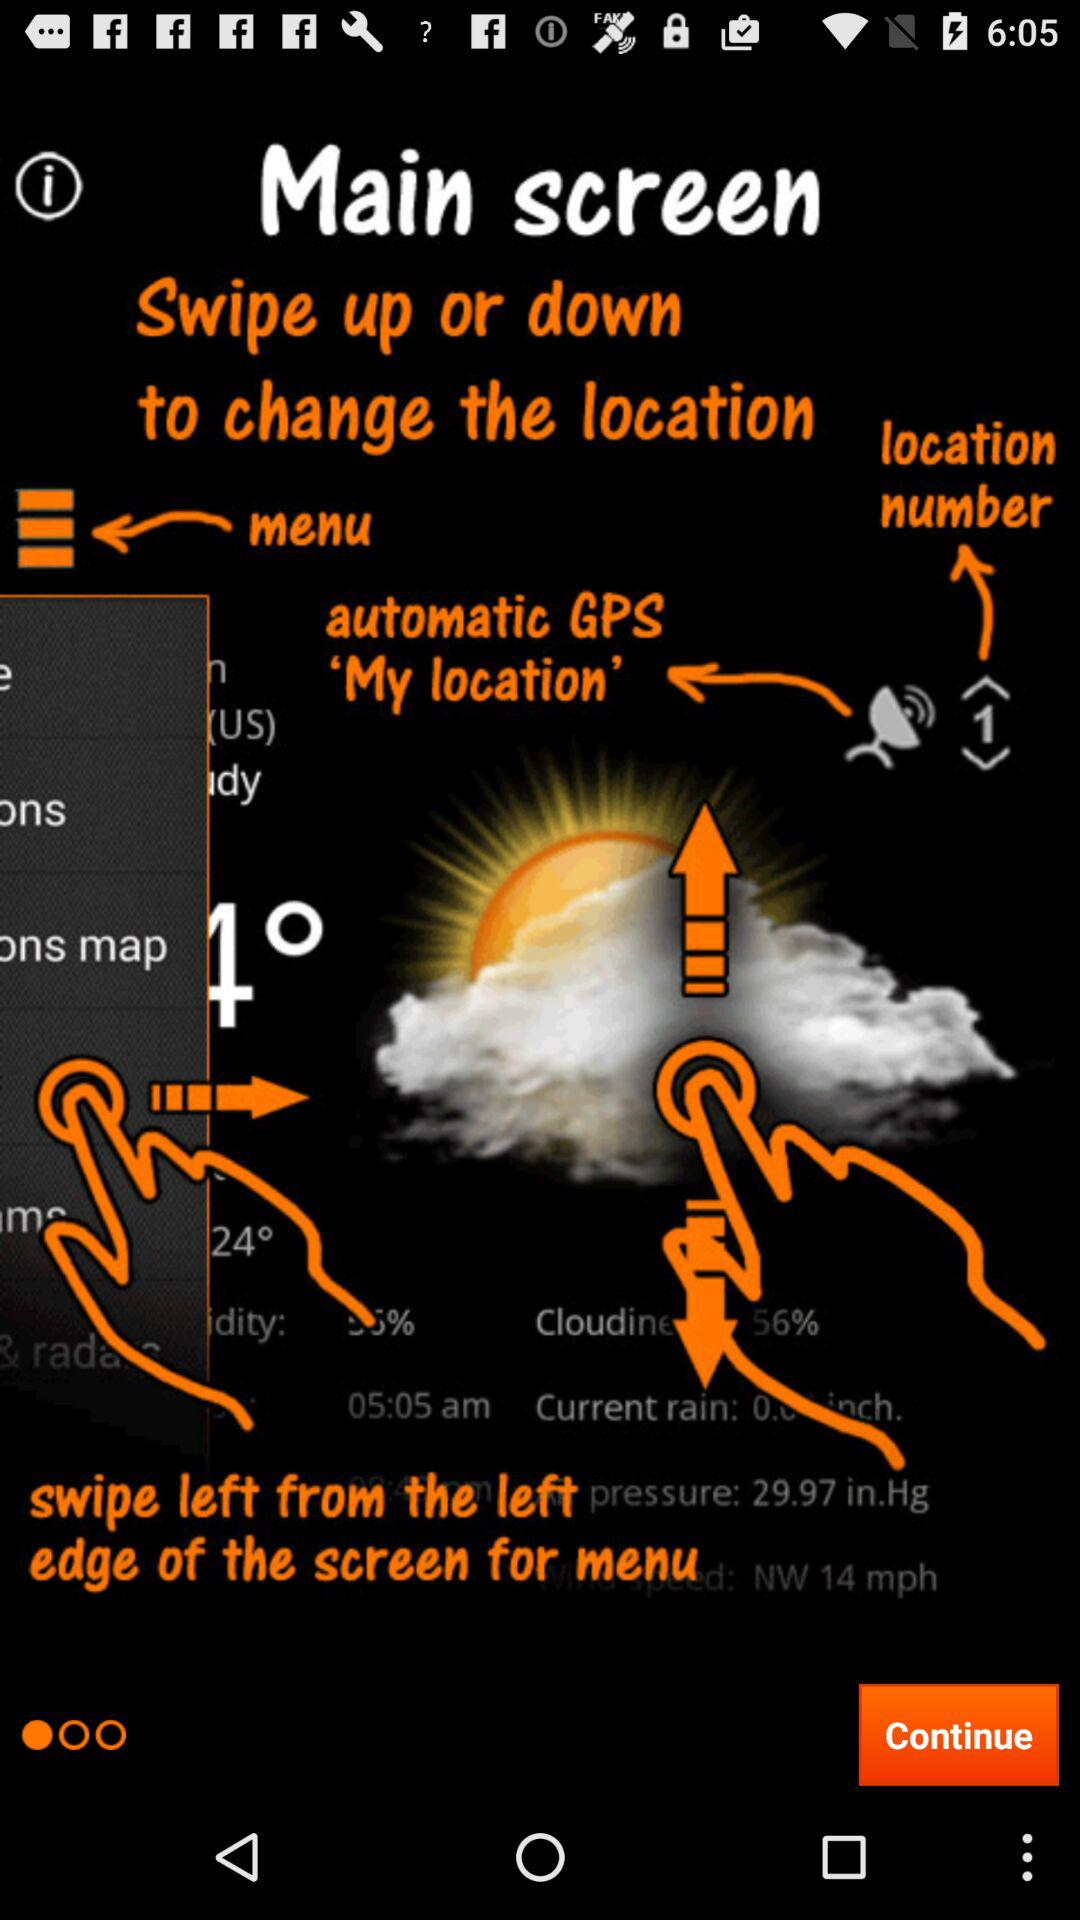What is the location number? The location number is 1. 